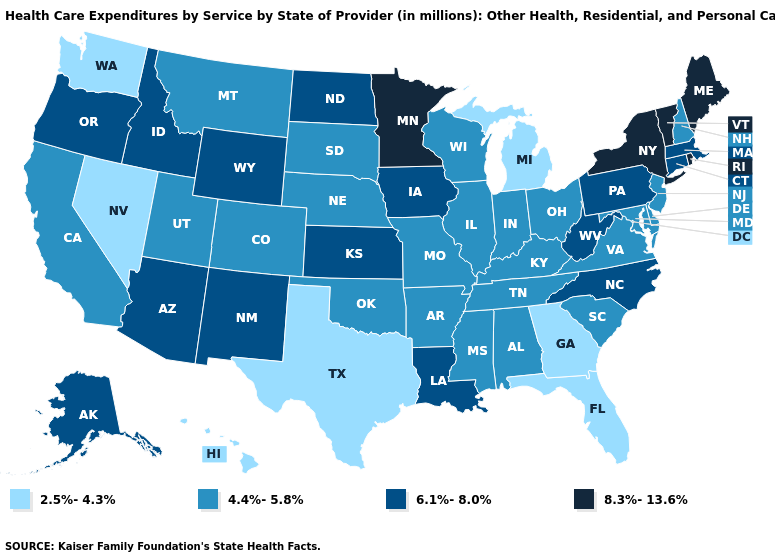Name the states that have a value in the range 8.3%-13.6%?
Keep it brief. Maine, Minnesota, New York, Rhode Island, Vermont. Which states have the highest value in the USA?
Quick response, please. Maine, Minnesota, New York, Rhode Island, Vermont. Name the states that have a value in the range 6.1%-8.0%?
Keep it brief. Alaska, Arizona, Connecticut, Idaho, Iowa, Kansas, Louisiana, Massachusetts, New Mexico, North Carolina, North Dakota, Oregon, Pennsylvania, West Virginia, Wyoming. Is the legend a continuous bar?
Quick response, please. No. Among the states that border Idaho , which have the lowest value?
Short answer required. Nevada, Washington. Does Wisconsin have a higher value than Michigan?
Write a very short answer. Yes. Is the legend a continuous bar?
Concise answer only. No. Does Alabama have a lower value than Oregon?
Write a very short answer. Yes. Is the legend a continuous bar?
Keep it brief. No. Name the states that have a value in the range 6.1%-8.0%?
Short answer required. Alaska, Arizona, Connecticut, Idaho, Iowa, Kansas, Louisiana, Massachusetts, New Mexico, North Carolina, North Dakota, Oregon, Pennsylvania, West Virginia, Wyoming. Name the states that have a value in the range 6.1%-8.0%?
Be succinct. Alaska, Arizona, Connecticut, Idaho, Iowa, Kansas, Louisiana, Massachusetts, New Mexico, North Carolina, North Dakota, Oregon, Pennsylvania, West Virginia, Wyoming. What is the value of Arizona?
Write a very short answer. 6.1%-8.0%. What is the lowest value in states that border Georgia?
Keep it brief. 2.5%-4.3%. Does Hawaii have the highest value in the West?
Write a very short answer. No. What is the highest value in states that border Illinois?
Give a very brief answer. 6.1%-8.0%. 